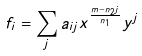Convert formula to latex. <formula><loc_0><loc_0><loc_500><loc_500>f _ { i } = \sum _ { j } a _ { i j } x ^ { \frac { m - n _ { 2 } j } { n _ { 1 } } } y ^ { j }</formula> 